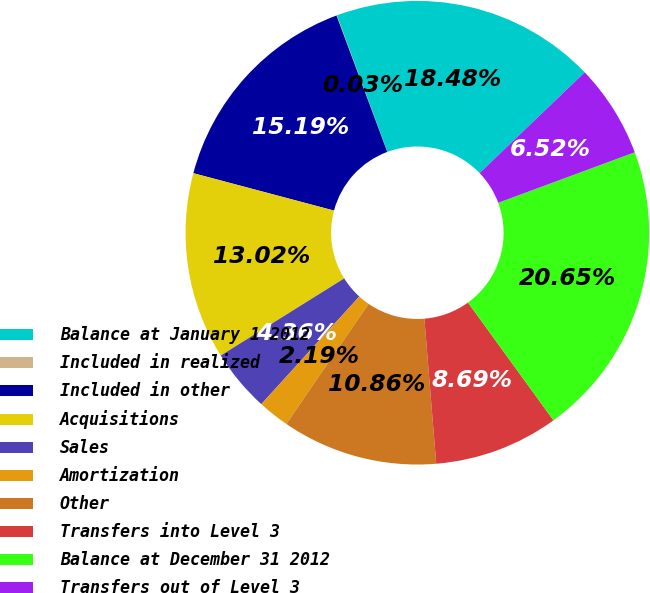<chart> <loc_0><loc_0><loc_500><loc_500><pie_chart><fcel>Balance at January 1 2012<fcel>Included in realized<fcel>Included in other<fcel>Acquisitions<fcel>Sales<fcel>Amortization<fcel>Other<fcel>Transfers into Level 3<fcel>Balance at December 31 2012<fcel>Transfers out of Level 3<nl><fcel>18.48%<fcel>0.03%<fcel>15.19%<fcel>13.02%<fcel>4.36%<fcel>2.19%<fcel>10.86%<fcel>8.69%<fcel>20.65%<fcel>6.52%<nl></chart> 